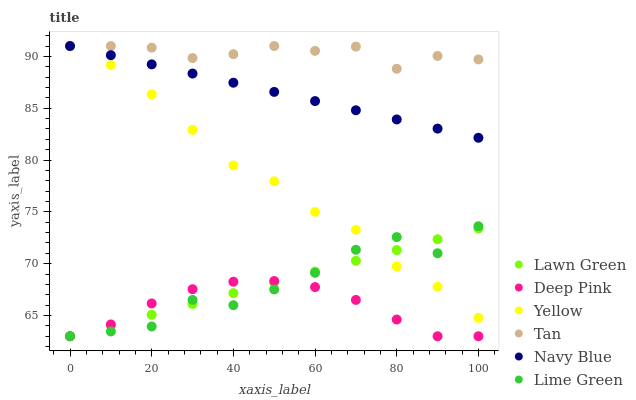Does Deep Pink have the minimum area under the curve?
Answer yes or no. Yes. Does Tan have the maximum area under the curve?
Answer yes or no. Yes. Does Navy Blue have the minimum area under the curve?
Answer yes or no. No. Does Navy Blue have the maximum area under the curve?
Answer yes or no. No. Is Lawn Green the smoothest?
Answer yes or no. Yes. Is Lime Green the roughest?
Answer yes or no. Yes. Is Deep Pink the smoothest?
Answer yes or no. No. Is Deep Pink the roughest?
Answer yes or no. No. Does Lawn Green have the lowest value?
Answer yes or no. Yes. Does Navy Blue have the lowest value?
Answer yes or no. No. Does Tan have the highest value?
Answer yes or no. Yes. Does Deep Pink have the highest value?
Answer yes or no. No. Is Deep Pink less than Navy Blue?
Answer yes or no. Yes. Is Yellow greater than Deep Pink?
Answer yes or no. Yes. Does Yellow intersect Lime Green?
Answer yes or no. Yes. Is Yellow less than Lime Green?
Answer yes or no. No. Is Yellow greater than Lime Green?
Answer yes or no. No. Does Deep Pink intersect Navy Blue?
Answer yes or no. No. 